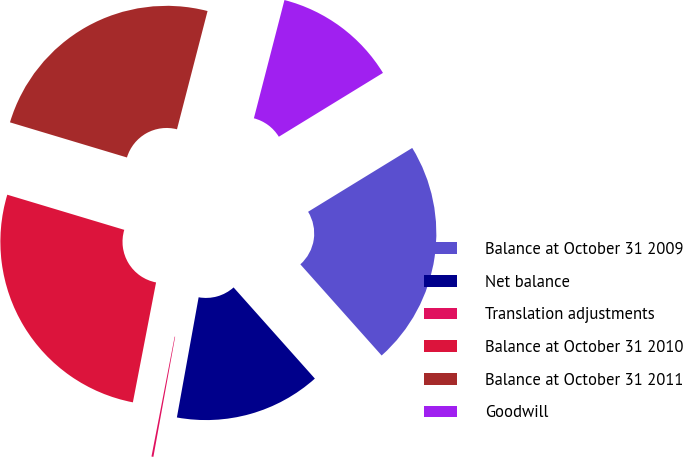Convert chart. <chart><loc_0><loc_0><loc_500><loc_500><pie_chart><fcel>Balance at October 31 2009<fcel>Net balance<fcel>Translation adjustments<fcel>Balance at October 31 2010<fcel>Balance at October 31 2011<fcel>Goodwill<nl><fcel>22.16%<fcel>14.44%<fcel>0.19%<fcel>26.6%<fcel>24.38%<fcel>12.22%<nl></chart> 